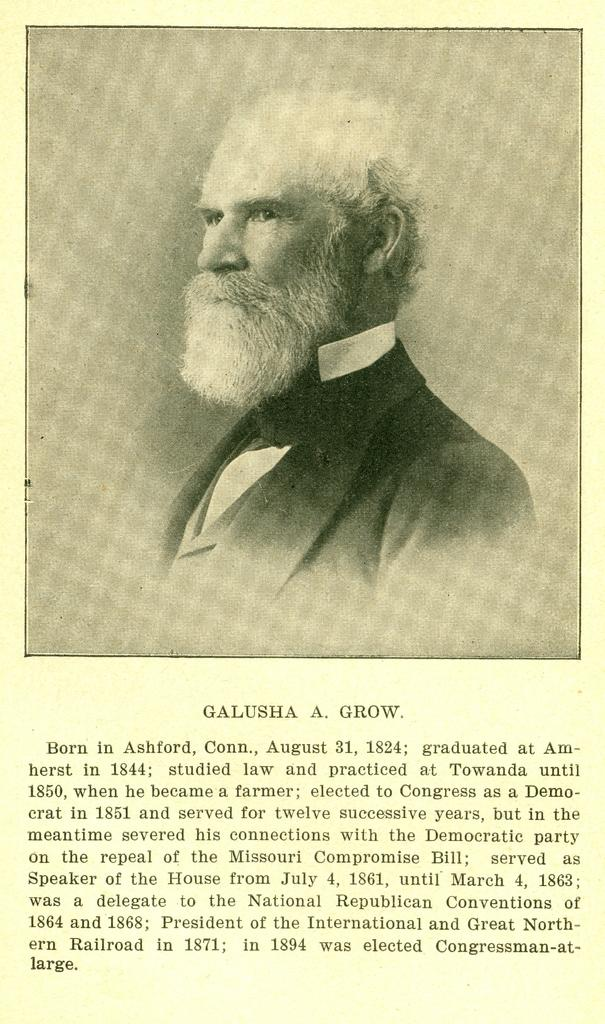What type of visual is the image in question? The image is a poster. What is depicted on the poster? There is an image of a man on the poster. Is there any text on the poster? Yes, there is text at the bottom of the poster. What country is the man in the image starting his journey from? There is no information about the man's journey or the country he is in within the image. 